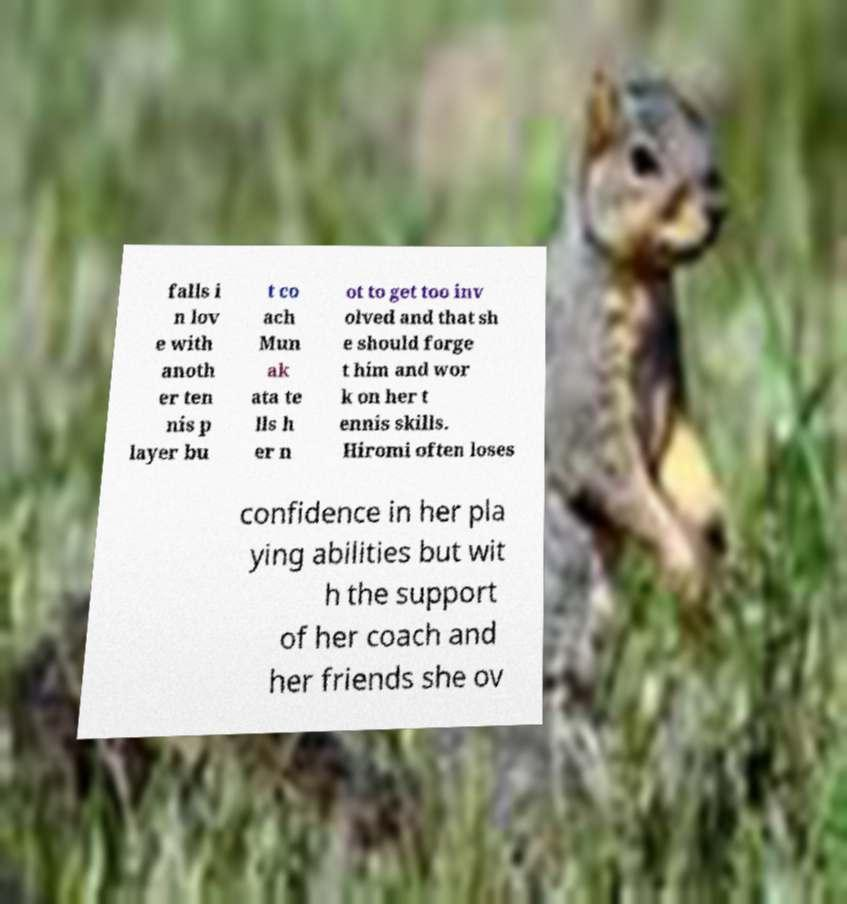Can you read and provide the text displayed in the image?This photo seems to have some interesting text. Can you extract and type it out for me? falls i n lov e with anoth er ten nis p layer bu t co ach Mun ak ata te lls h er n ot to get too inv olved and that sh e should forge t him and wor k on her t ennis skills. Hiromi often loses confidence in her pla ying abilities but wit h the support of her coach and her friends she ov 